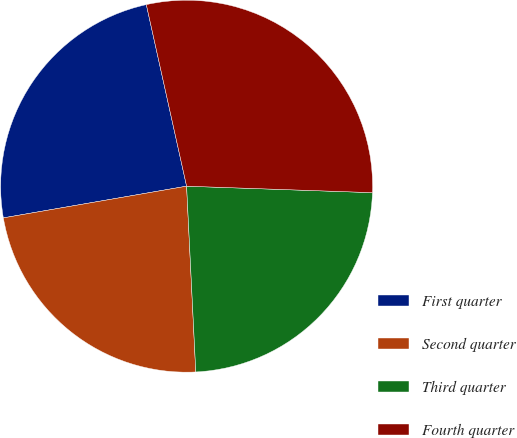Convert chart. <chart><loc_0><loc_0><loc_500><loc_500><pie_chart><fcel>First quarter<fcel>Second quarter<fcel>Third quarter<fcel>Fourth quarter<nl><fcel>24.25%<fcel>23.06%<fcel>23.66%<fcel>29.03%<nl></chart> 